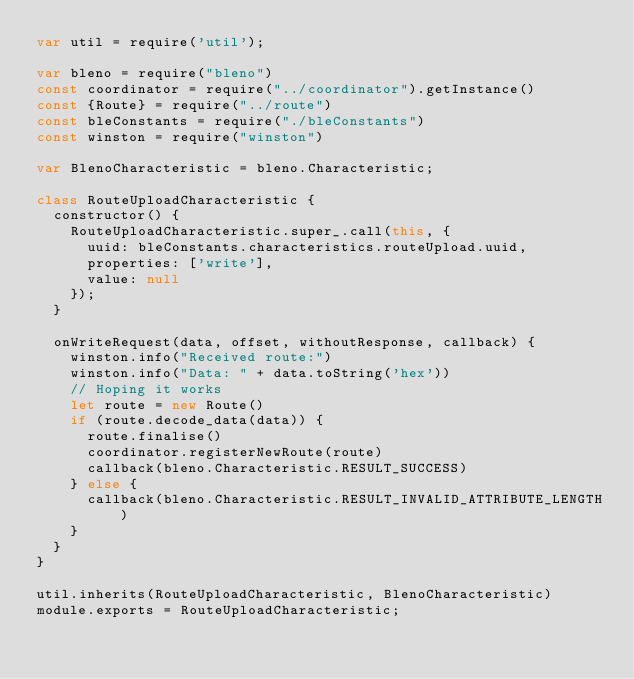Convert code to text. <code><loc_0><loc_0><loc_500><loc_500><_JavaScript_>var util = require('util');

var bleno = require("bleno")
const coordinator = require("../coordinator").getInstance()
const {Route} = require("../route")
const bleConstants = require("./bleConstants")
const winston = require("winston")

var BlenoCharacteristic = bleno.Characteristic;

class RouteUploadCharacteristic {
  constructor() {
    RouteUploadCharacteristic.super_.call(this, {
      uuid: bleConstants.characteristics.routeUpload.uuid,
      properties: ['write'],
      value: null
    });
  }

  onWriteRequest(data, offset, withoutResponse, callback) {
    winston.info("Received route:")
    winston.info("Data: " + data.toString('hex'))
    // Hoping it works
    let route = new Route()
    if (route.decode_data(data)) {
      route.finalise()
      coordinator.registerNewRoute(route)
      callback(bleno.Characteristic.RESULT_SUCCESS)
    } else {
      callback(bleno.Characteristic.RESULT_INVALID_ATTRIBUTE_LENGTH)
    }
  }
}

util.inherits(RouteUploadCharacteristic, BlenoCharacteristic)
module.exports = RouteUploadCharacteristic;
</code> 